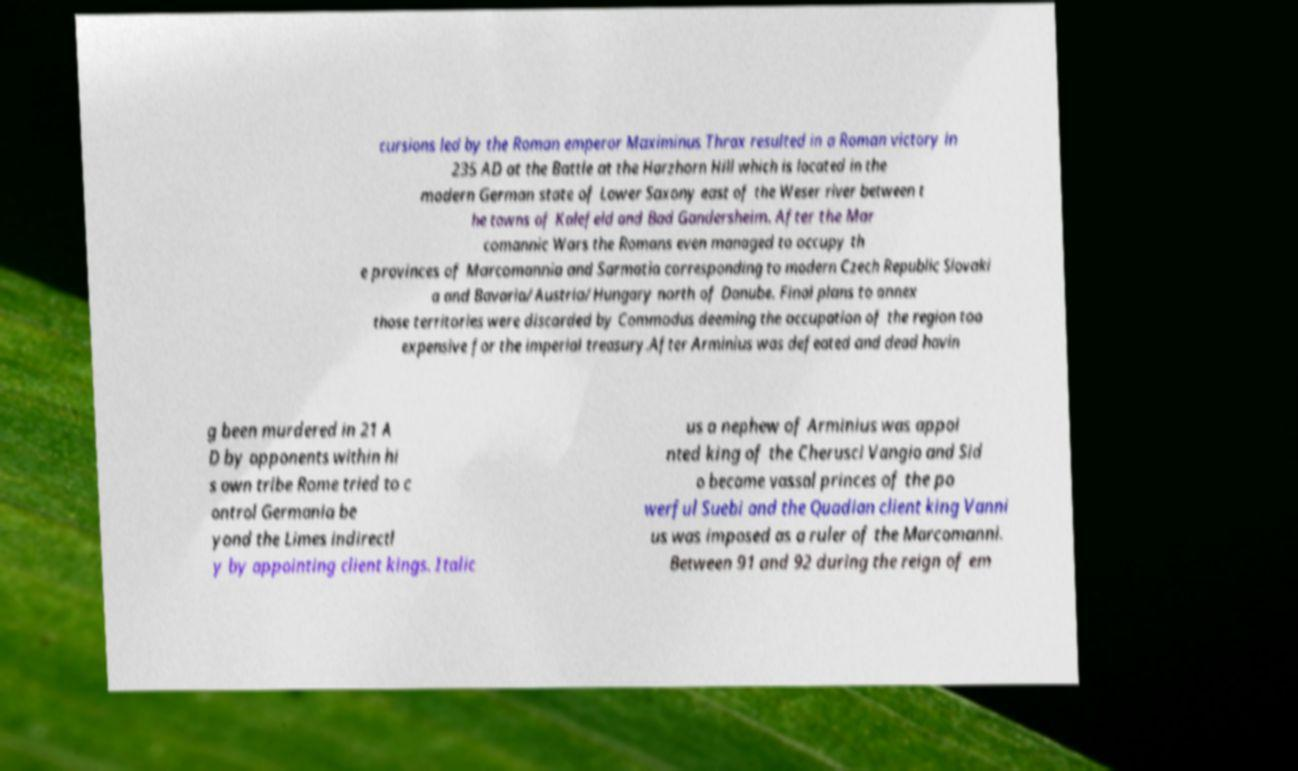Please identify and transcribe the text found in this image. cursions led by the Roman emperor Maximinus Thrax resulted in a Roman victory in 235 AD at the Battle at the Harzhorn Hill which is located in the modern German state of Lower Saxony east of the Weser river between t he towns of Kalefeld and Bad Gandersheim. After the Mar comannic Wars the Romans even managed to occupy th e provinces of Marcomannia and Sarmatia corresponding to modern Czech Republic Slovaki a and Bavaria/Austria/Hungary north of Danube. Final plans to annex those territories were discarded by Commodus deeming the occupation of the region too expensive for the imperial treasury.After Arminius was defeated and dead havin g been murdered in 21 A D by opponents within hi s own tribe Rome tried to c ontrol Germania be yond the Limes indirectl y by appointing client kings. Italic us a nephew of Arminius was appoi nted king of the Cherusci Vangio and Sid o became vassal princes of the po werful Suebi and the Quadian client king Vanni us was imposed as a ruler of the Marcomanni. Between 91 and 92 during the reign of em 